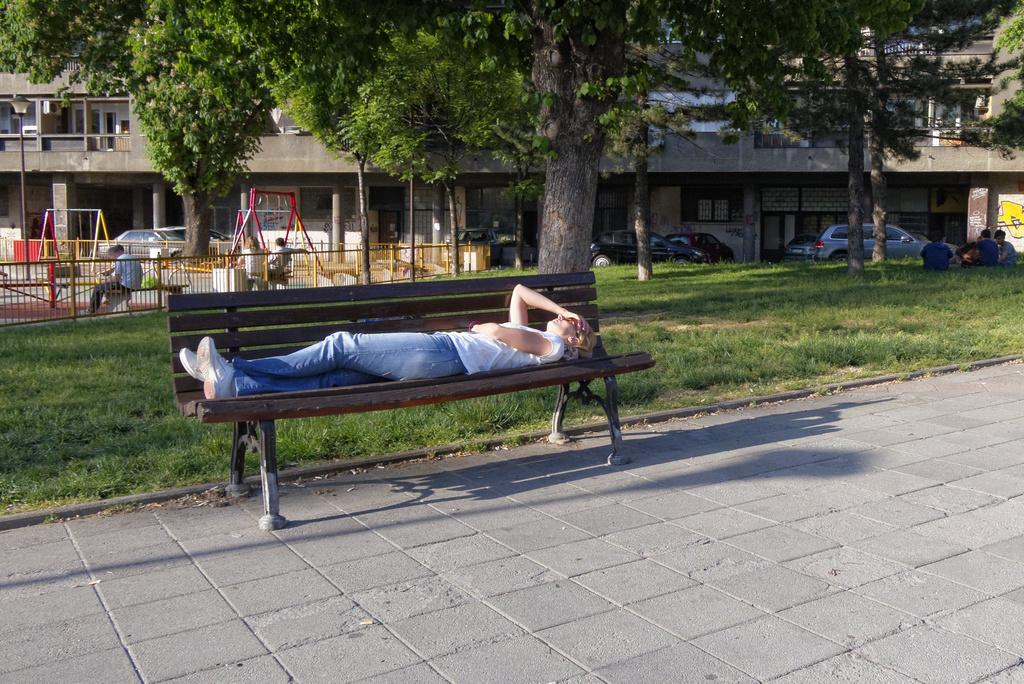What is the person in the image doing? The person is lying on a bench in the image. What can be seen in the foreground of the image? There is a path visible in the image. What type of natural environment is present in the background of the image? There is grass, trees, and a building in the background of the image. What else can be seen in the background of the image? There are people and cars in the background of the image. What type of cloud is present in the image? There is no cloud present in the image; the sky is not visible. What kind of pets can be seen accompanying the person on the bench in the image? There are no pets visible in the image; only the person lying on the bench is present. 